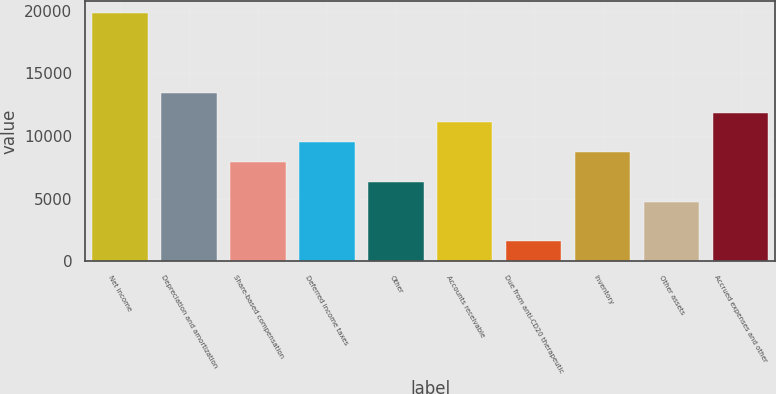Convert chart. <chart><loc_0><loc_0><loc_500><loc_500><bar_chart><fcel>Net income<fcel>Depreciation and amortization<fcel>Share-based compensation<fcel>Deferred income taxes<fcel>Other<fcel>Accounts receivable<fcel>Due from anti-CD20 therapeutic<fcel>Inventory<fcel>Other assets<fcel>Accrued expenses and other<nl><fcel>19779<fcel>13450.5<fcel>7913.2<fcel>9495.3<fcel>6331.1<fcel>11077.4<fcel>1584.8<fcel>8704.25<fcel>4749<fcel>11868.5<nl></chart> 